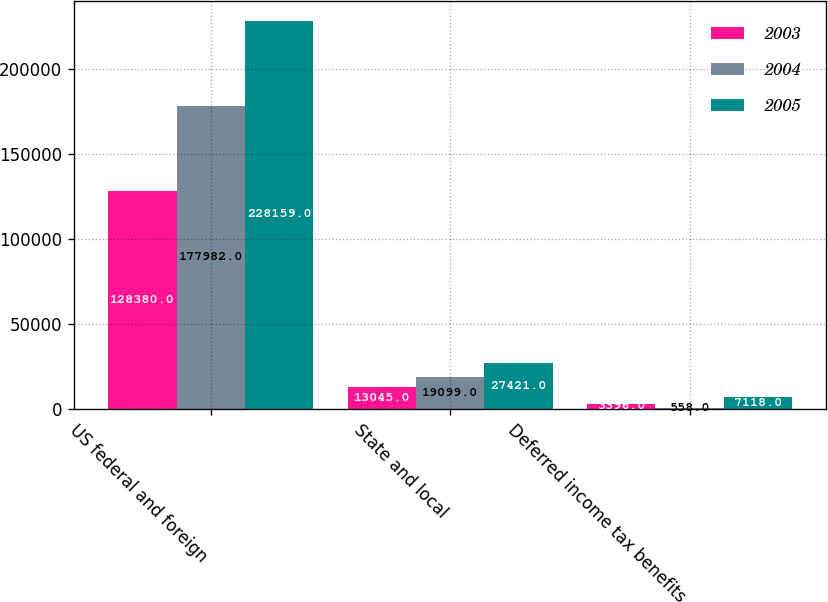Convert chart. <chart><loc_0><loc_0><loc_500><loc_500><stacked_bar_chart><ecel><fcel>US federal and foreign<fcel>State and local<fcel>Deferred income tax benefits<nl><fcel>2003<fcel>128380<fcel>13045<fcel>3396<nl><fcel>2004<fcel>177982<fcel>19099<fcel>558<nl><fcel>2005<fcel>228159<fcel>27421<fcel>7118<nl></chart> 